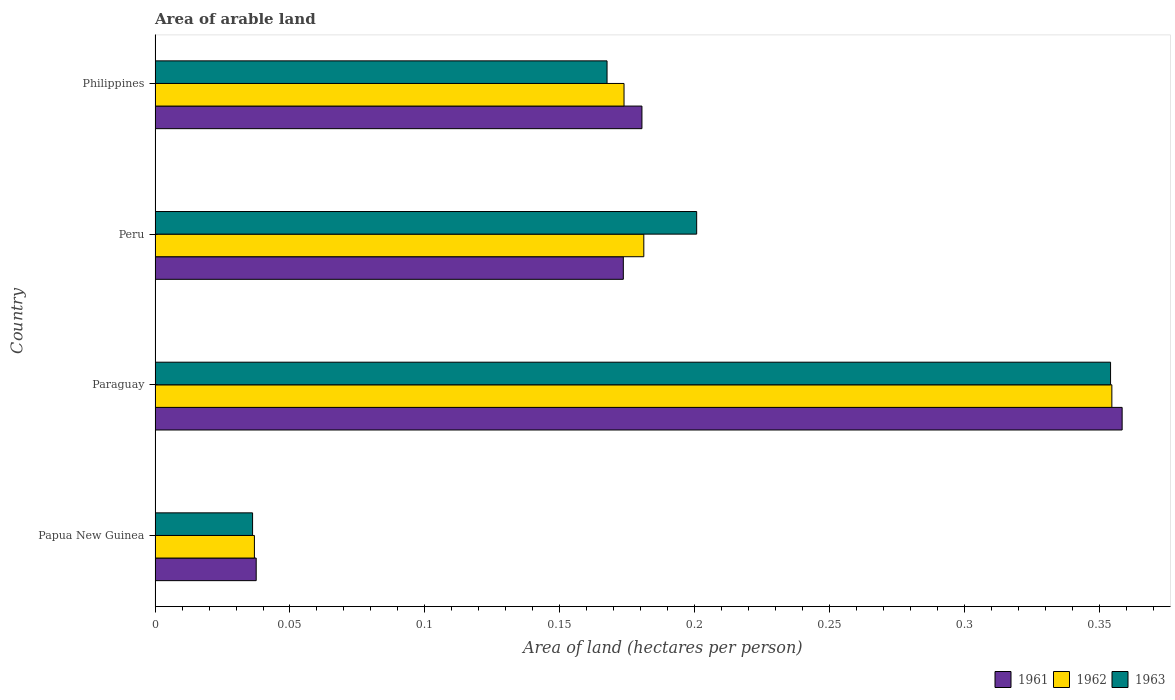How many different coloured bars are there?
Offer a terse response. 3. How many groups of bars are there?
Make the answer very short. 4. How many bars are there on the 2nd tick from the top?
Your answer should be very brief. 3. How many bars are there on the 3rd tick from the bottom?
Your answer should be very brief. 3. In how many cases, is the number of bars for a given country not equal to the number of legend labels?
Your answer should be compact. 0. What is the total arable land in 1961 in Papua New Guinea?
Provide a succinct answer. 0.04. Across all countries, what is the maximum total arable land in 1961?
Offer a very short reply. 0.36. Across all countries, what is the minimum total arable land in 1962?
Your response must be concise. 0.04. In which country was the total arable land in 1961 maximum?
Your answer should be very brief. Paraguay. In which country was the total arable land in 1963 minimum?
Keep it short and to the point. Papua New Guinea. What is the total total arable land in 1963 in the graph?
Give a very brief answer. 0.76. What is the difference between the total arable land in 1962 in Peru and that in Philippines?
Provide a succinct answer. 0.01. What is the difference between the total arable land in 1961 in Philippines and the total arable land in 1963 in Paraguay?
Make the answer very short. -0.17. What is the average total arable land in 1963 per country?
Provide a succinct answer. 0.19. What is the difference between the total arable land in 1963 and total arable land in 1961 in Philippines?
Your answer should be very brief. -0.01. What is the ratio of the total arable land in 1963 in Papua New Guinea to that in Peru?
Provide a short and direct response. 0.18. What is the difference between the highest and the second highest total arable land in 1961?
Offer a terse response. 0.18. What is the difference between the highest and the lowest total arable land in 1961?
Offer a very short reply. 0.32. Is the sum of the total arable land in 1962 in Paraguay and Philippines greater than the maximum total arable land in 1961 across all countries?
Your answer should be compact. Yes. How many bars are there?
Give a very brief answer. 12. Are all the bars in the graph horizontal?
Offer a terse response. Yes. What is the difference between two consecutive major ticks on the X-axis?
Provide a succinct answer. 0.05. Does the graph contain any zero values?
Offer a very short reply. No. Does the graph contain grids?
Ensure brevity in your answer.  No. How are the legend labels stacked?
Keep it short and to the point. Horizontal. What is the title of the graph?
Give a very brief answer. Area of arable land. What is the label or title of the X-axis?
Ensure brevity in your answer.  Area of land (hectares per person). What is the Area of land (hectares per person) of 1961 in Papua New Guinea?
Provide a short and direct response. 0.04. What is the Area of land (hectares per person) in 1962 in Papua New Guinea?
Your answer should be very brief. 0.04. What is the Area of land (hectares per person) in 1963 in Papua New Guinea?
Give a very brief answer. 0.04. What is the Area of land (hectares per person) of 1961 in Paraguay?
Your answer should be very brief. 0.36. What is the Area of land (hectares per person) of 1962 in Paraguay?
Offer a terse response. 0.35. What is the Area of land (hectares per person) in 1963 in Paraguay?
Your answer should be compact. 0.35. What is the Area of land (hectares per person) in 1961 in Peru?
Give a very brief answer. 0.17. What is the Area of land (hectares per person) in 1962 in Peru?
Provide a short and direct response. 0.18. What is the Area of land (hectares per person) in 1963 in Peru?
Your answer should be compact. 0.2. What is the Area of land (hectares per person) of 1961 in Philippines?
Your answer should be compact. 0.18. What is the Area of land (hectares per person) of 1962 in Philippines?
Offer a terse response. 0.17. What is the Area of land (hectares per person) of 1963 in Philippines?
Keep it short and to the point. 0.17. Across all countries, what is the maximum Area of land (hectares per person) in 1961?
Make the answer very short. 0.36. Across all countries, what is the maximum Area of land (hectares per person) in 1962?
Offer a very short reply. 0.35. Across all countries, what is the maximum Area of land (hectares per person) of 1963?
Your answer should be compact. 0.35. Across all countries, what is the minimum Area of land (hectares per person) in 1961?
Offer a very short reply. 0.04. Across all countries, what is the minimum Area of land (hectares per person) in 1962?
Ensure brevity in your answer.  0.04. Across all countries, what is the minimum Area of land (hectares per person) in 1963?
Ensure brevity in your answer.  0.04. What is the total Area of land (hectares per person) in 1961 in the graph?
Your response must be concise. 0.75. What is the total Area of land (hectares per person) in 1962 in the graph?
Ensure brevity in your answer.  0.75. What is the total Area of land (hectares per person) in 1963 in the graph?
Keep it short and to the point. 0.76. What is the difference between the Area of land (hectares per person) in 1961 in Papua New Guinea and that in Paraguay?
Give a very brief answer. -0.32. What is the difference between the Area of land (hectares per person) in 1962 in Papua New Guinea and that in Paraguay?
Provide a succinct answer. -0.32. What is the difference between the Area of land (hectares per person) in 1963 in Papua New Guinea and that in Paraguay?
Your response must be concise. -0.32. What is the difference between the Area of land (hectares per person) of 1961 in Papua New Guinea and that in Peru?
Ensure brevity in your answer.  -0.14. What is the difference between the Area of land (hectares per person) in 1962 in Papua New Guinea and that in Peru?
Keep it short and to the point. -0.14. What is the difference between the Area of land (hectares per person) in 1963 in Papua New Guinea and that in Peru?
Provide a succinct answer. -0.16. What is the difference between the Area of land (hectares per person) in 1961 in Papua New Guinea and that in Philippines?
Provide a succinct answer. -0.14. What is the difference between the Area of land (hectares per person) of 1962 in Papua New Guinea and that in Philippines?
Offer a very short reply. -0.14. What is the difference between the Area of land (hectares per person) in 1963 in Papua New Guinea and that in Philippines?
Give a very brief answer. -0.13. What is the difference between the Area of land (hectares per person) in 1961 in Paraguay and that in Peru?
Ensure brevity in your answer.  0.18. What is the difference between the Area of land (hectares per person) in 1962 in Paraguay and that in Peru?
Offer a terse response. 0.17. What is the difference between the Area of land (hectares per person) of 1963 in Paraguay and that in Peru?
Provide a succinct answer. 0.15. What is the difference between the Area of land (hectares per person) in 1961 in Paraguay and that in Philippines?
Offer a terse response. 0.18. What is the difference between the Area of land (hectares per person) of 1962 in Paraguay and that in Philippines?
Your answer should be compact. 0.18. What is the difference between the Area of land (hectares per person) in 1963 in Paraguay and that in Philippines?
Your answer should be very brief. 0.19. What is the difference between the Area of land (hectares per person) in 1961 in Peru and that in Philippines?
Ensure brevity in your answer.  -0.01. What is the difference between the Area of land (hectares per person) in 1962 in Peru and that in Philippines?
Make the answer very short. 0.01. What is the difference between the Area of land (hectares per person) in 1963 in Peru and that in Philippines?
Your answer should be very brief. 0.03. What is the difference between the Area of land (hectares per person) of 1961 in Papua New Guinea and the Area of land (hectares per person) of 1962 in Paraguay?
Keep it short and to the point. -0.32. What is the difference between the Area of land (hectares per person) of 1961 in Papua New Guinea and the Area of land (hectares per person) of 1963 in Paraguay?
Provide a succinct answer. -0.32. What is the difference between the Area of land (hectares per person) in 1962 in Papua New Guinea and the Area of land (hectares per person) in 1963 in Paraguay?
Give a very brief answer. -0.32. What is the difference between the Area of land (hectares per person) of 1961 in Papua New Guinea and the Area of land (hectares per person) of 1962 in Peru?
Offer a very short reply. -0.14. What is the difference between the Area of land (hectares per person) in 1961 in Papua New Guinea and the Area of land (hectares per person) in 1963 in Peru?
Make the answer very short. -0.16. What is the difference between the Area of land (hectares per person) in 1962 in Papua New Guinea and the Area of land (hectares per person) in 1963 in Peru?
Provide a short and direct response. -0.16. What is the difference between the Area of land (hectares per person) in 1961 in Papua New Guinea and the Area of land (hectares per person) in 1962 in Philippines?
Your answer should be compact. -0.14. What is the difference between the Area of land (hectares per person) of 1961 in Papua New Guinea and the Area of land (hectares per person) of 1963 in Philippines?
Provide a short and direct response. -0.13. What is the difference between the Area of land (hectares per person) in 1962 in Papua New Guinea and the Area of land (hectares per person) in 1963 in Philippines?
Offer a terse response. -0.13. What is the difference between the Area of land (hectares per person) of 1961 in Paraguay and the Area of land (hectares per person) of 1962 in Peru?
Provide a succinct answer. 0.18. What is the difference between the Area of land (hectares per person) of 1961 in Paraguay and the Area of land (hectares per person) of 1963 in Peru?
Make the answer very short. 0.16. What is the difference between the Area of land (hectares per person) of 1962 in Paraguay and the Area of land (hectares per person) of 1963 in Peru?
Provide a succinct answer. 0.15. What is the difference between the Area of land (hectares per person) in 1961 in Paraguay and the Area of land (hectares per person) in 1962 in Philippines?
Offer a terse response. 0.18. What is the difference between the Area of land (hectares per person) of 1961 in Paraguay and the Area of land (hectares per person) of 1963 in Philippines?
Provide a short and direct response. 0.19. What is the difference between the Area of land (hectares per person) in 1962 in Paraguay and the Area of land (hectares per person) in 1963 in Philippines?
Your answer should be compact. 0.19. What is the difference between the Area of land (hectares per person) of 1961 in Peru and the Area of land (hectares per person) of 1962 in Philippines?
Your answer should be compact. -0. What is the difference between the Area of land (hectares per person) in 1961 in Peru and the Area of land (hectares per person) in 1963 in Philippines?
Ensure brevity in your answer.  0.01. What is the difference between the Area of land (hectares per person) in 1962 in Peru and the Area of land (hectares per person) in 1963 in Philippines?
Offer a terse response. 0.01. What is the average Area of land (hectares per person) of 1961 per country?
Your answer should be very brief. 0.19. What is the average Area of land (hectares per person) of 1962 per country?
Keep it short and to the point. 0.19. What is the average Area of land (hectares per person) of 1963 per country?
Make the answer very short. 0.19. What is the difference between the Area of land (hectares per person) of 1961 and Area of land (hectares per person) of 1962 in Papua New Guinea?
Your response must be concise. 0. What is the difference between the Area of land (hectares per person) in 1961 and Area of land (hectares per person) in 1963 in Papua New Guinea?
Provide a short and direct response. 0. What is the difference between the Area of land (hectares per person) in 1962 and Area of land (hectares per person) in 1963 in Papua New Guinea?
Your answer should be very brief. 0. What is the difference between the Area of land (hectares per person) in 1961 and Area of land (hectares per person) in 1962 in Paraguay?
Keep it short and to the point. 0. What is the difference between the Area of land (hectares per person) in 1961 and Area of land (hectares per person) in 1963 in Paraguay?
Make the answer very short. 0. What is the difference between the Area of land (hectares per person) of 1962 and Area of land (hectares per person) of 1963 in Paraguay?
Provide a short and direct response. 0. What is the difference between the Area of land (hectares per person) of 1961 and Area of land (hectares per person) of 1962 in Peru?
Give a very brief answer. -0.01. What is the difference between the Area of land (hectares per person) of 1961 and Area of land (hectares per person) of 1963 in Peru?
Keep it short and to the point. -0.03. What is the difference between the Area of land (hectares per person) in 1962 and Area of land (hectares per person) in 1963 in Peru?
Offer a terse response. -0.02. What is the difference between the Area of land (hectares per person) of 1961 and Area of land (hectares per person) of 1962 in Philippines?
Keep it short and to the point. 0.01. What is the difference between the Area of land (hectares per person) in 1961 and Area of land (hectares per person) in 1963 in Philippines?
Offer a very short reply. 0.01. What is the difference between the Area of land (hectares per person) of 1962 and Area of land (hectares per person) of 1963 in Philippines?
Your answer should be very brief. 0.01. What is the ratio of the Area of land (hectares per person) in 1961 in Papua New Guinea to that in Paraguay?
Offer a terse response. 0.1. What is the ratio of the Area of land (hectares per person) of 1962 in Papua New Guinea to that in Paraguay?
Make the answer very short. 0.1. What is the ratio of the Area of land (hectares per person) of 1963 in Papua New Guinea to that in Paraguay?
Offer a very short reply. 0.1. What is the ratio of the Area of land (hectares per person) in 1961 in Papua New Guinea to that in Peru?
Provide a short and direct response. 0.22. What is the ratio of the Area of land (hectares per person) in 1962 in Papua New Guinea to that in Peru?
Your answer should be very brief. 0.2. What is the ratio of the Area of land (hectares per person) of 1963 in Papua New Guinea to that in Peru?
Keep it short and to the point. 0.18. What is the ratio of the Area of land (hectares per person) in 1961 in Papua New Guinea to that in Philippines?
Your response must be concise. 0.21. What is the ratio of the Area of land (hectares per person) in 1962 in Papua New Guinea to that in Philippines?
Offer a terse response. 0.21. What is the ratio of the Area of land (hectares per person) of 1963 in Papua New Guinea to that in Philippines?
Ensure brevity in your answer.  0.22. What is the ratio of the Area of land (hectares per person) of 1961 in Paraguay to that in Peru?
Your answer should be compact. 2.07. What is the ratio of the Area of land (hectares per person) of 1962 in Paraguay to that in Peru?
Provide a succinct answer. 1.96. What is the ratio of the Area of land (hectares per person) in 1963 in Paraguay to that in Peru?
Offer a very short reply. 1.76. What is the ratio of the Area of land (hectares per person) of 1961 in Paraguay to that in Philippines?
Your answer should be very brief. 1.99. What is the ratio of the Area of land (hectares per person) in 1962 in Paraguay to that in Philippines?
Provide a succinct answer. 2.04. What is the ratio of the Area of land (hectares per person) of 1963 in Paraguay to that in Philippines?
Your answer should be compact. 2.11. What is the ratio of the Area of land (hectares per person) of 1961 in Peru to that in Philippines?
Your response must be concise. 0.96. What is the ratio of the Area of land (hectares per person) of 1962 in Peru to that in Philippines?
Make the answer very short. 1.04. What is the ratio of the Area of land (hectares per person) of 1963 in Peru to that in Philippines?
Keep it short and to the point. 1.2. What is the difference between the highest and the second highest Area of land (hectares per person) in 1961?
Ensure brevity in your answer.  0.18. What is the difference between the highest and the second highest Area of land (hectares per person) in 1962?
Make the answer very short. 0.17. What is the difference between the highest and the second highest Area of land (hectares per person) in 1963?
Offer a very short reply. 0.15. What is the difference between the highest and the lowest Area of land (hectares per person) in 1961?
Provide a short and direct response. 0.32. What is the difference between the highest and the lowest Area of land (hectares per person) of 1962?
Your answer should be compact. 0.32. What is the difference between the highest and the lowest Area of land (hectares per person) in 1963?
Give a very brief answer. 0.32. 